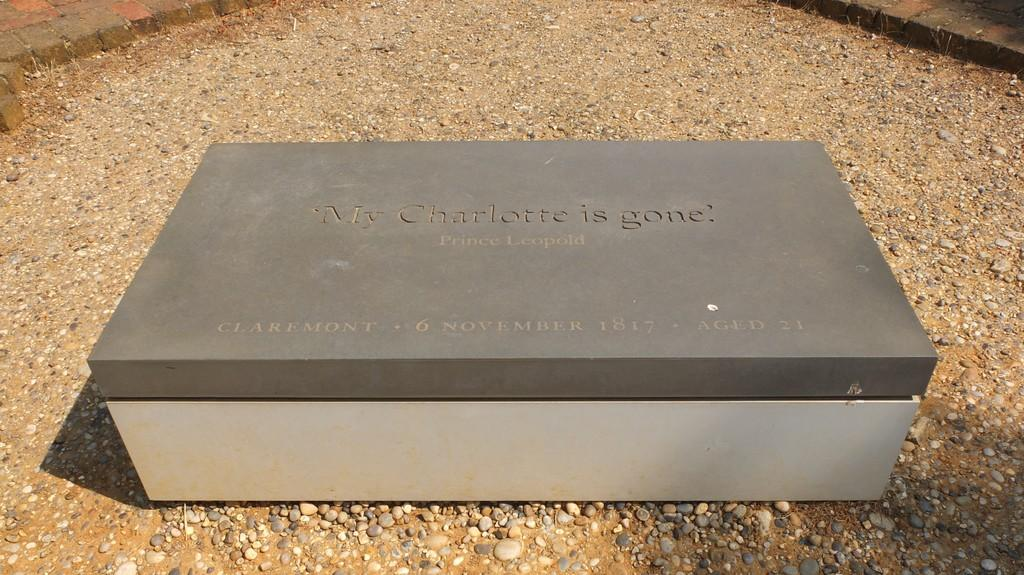<image>
Relay a brief, clear account of the picture shown. Some sort of gravestone reading "My Charlotte is gone" on the top of it. 